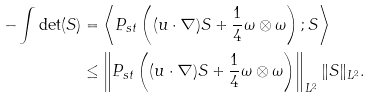Convert formula to latex. <formula><loc_0><loc_0><loc_500><loc_500>- \int \det ( S ) & = \left < P _ { s t } \left ( ( u \cdot \nabla ) S + \frac { 1 } { 4 } \omega \otimes \omega \right ) ; S \right > \\ & \leq \left \| P _ { s t } \left ( ( u \cdot \nabla ) S + \frac { 1 } { 4 } \omega \otimes \omega \right ) \right \| _ { L ^ { 2 } } \| S \| _ { L ^ { 2 } } .</formula> 